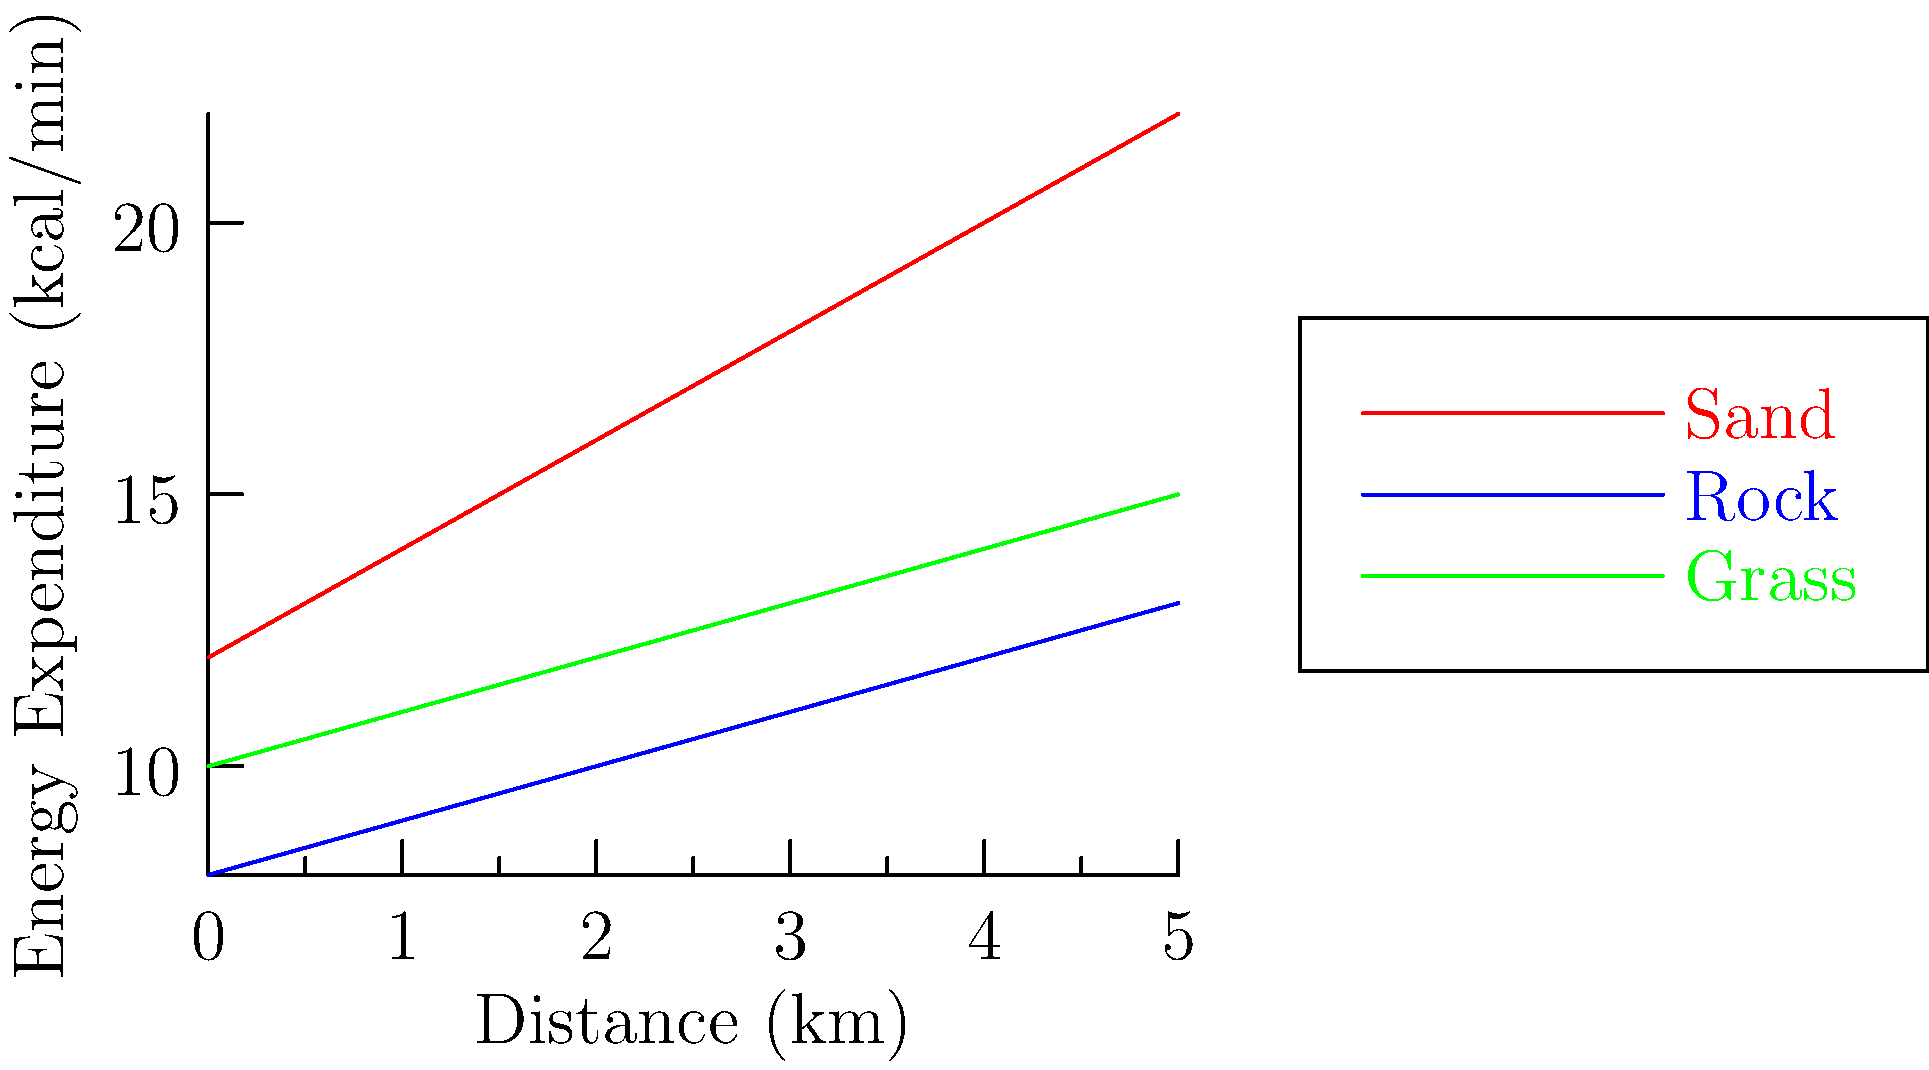Given the graph showing energy expenditure while running on different terrains in Djibouti, which surface requires the most energy for a 5 km run, and how much more energy (in kcal) does it require compared to the least energy-intensive surface? To solve this problem, let's follow these steps:

1. Identify the surfaces:
   - Sand (red line)
   - Rock (blue line)
   - Grass (green line)

2. Determine energy expenditure at 5 km for each surface:
   - Sand: 22 kcal/min
   - Rock: 13 kcal/min
   - Grass: 15 kcal/min

3. Identify the most and least energy-intensive surfaces:
   - Most energy-intensive: Sand (22 kcal/min)
   - Least energy-intensive: Rock (13 kcal/min)

4. Calculate the difference in energy expenditure:
   $$\text{Difference} = \text{Sand} - \text{Rock} = 22 - 13 = 9 \text{ kcal/min}$$

5. Calculate total energy difference for a 5 km run:
   Assuming an average running speed of 10 km/h (5 km in 30 minutes):
   $$\text{Total energy difference} = 9 \text{ kcal/min} \times 30 \text{ min} = 270 \text{ kcal}$$

Therefore, running on sand requires 270 kcal more energy than running on rock for a 5 km distance in Djibouti's terrain.
Answer: Sand; 270 kcal 